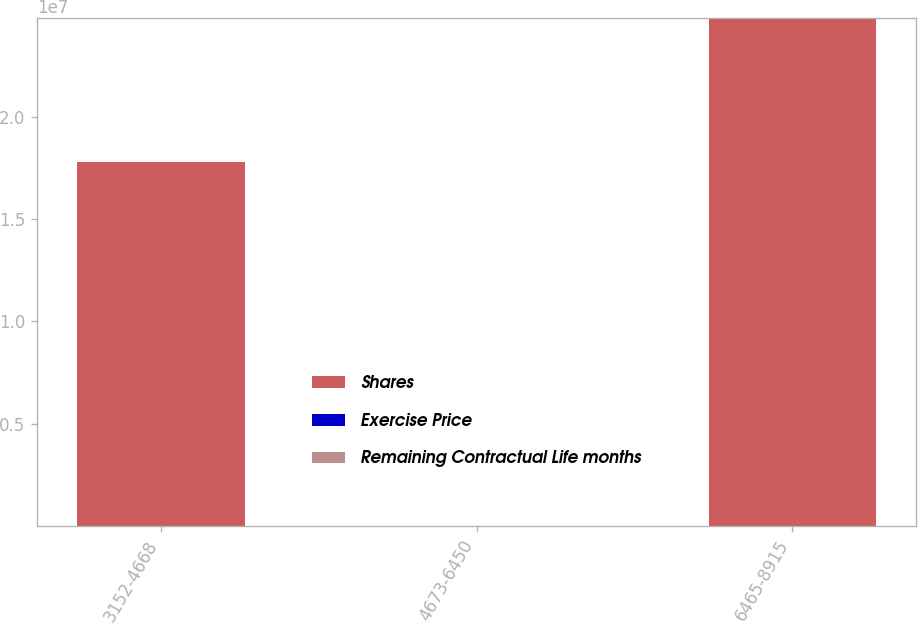Convert chart. <chart><loc_0><loc_0><loc_500><loc_500><stacked_bar_chart><ecel><fcel>3152-4668<fcel>4673-6450<fcel>6465-8915<nl><fcel>Shares<fcel>1.78068e+07<fcel>74.845<fcel>2.48262e+07<nl><fcel>Exercise Price<fcel>30<fcel>69<fcel>102<nl><fcel>Remaining Contractual Life months<fcel>43.3<fcel>59.37<fcel>80.69<nl></chart> 